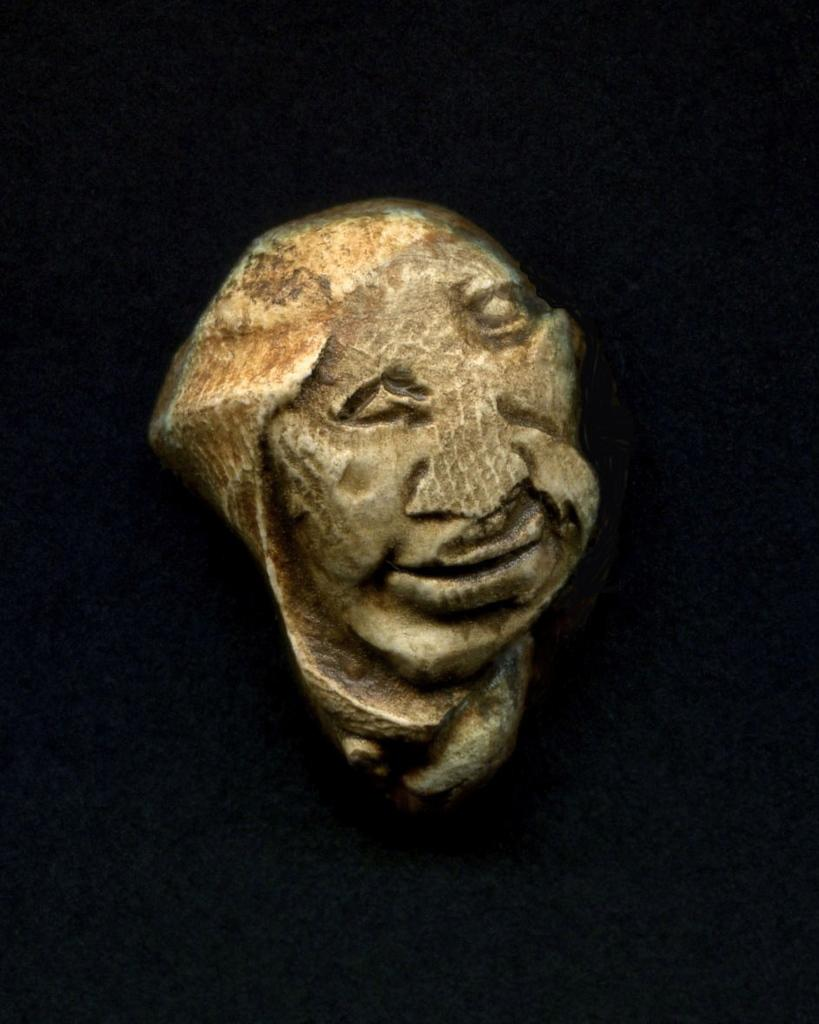What is the main subject in the center of the image? There is a sculpture in the center of the image. How many family members can be seen interacting with the sculpture in the image? There are no family members present in the image; it only features a sculpture. What type of expansion is visible on the sculpture in the image? There is no expansion visible on the sculpture in the image, as it is a static object. 